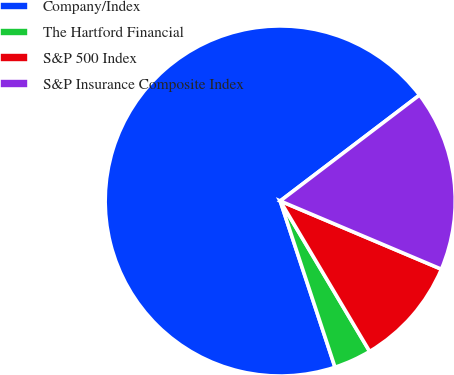<chart> <loc_0><loc_0><loc_500><loc_500><pie_chart><fcel>Company/Index<fcel>The Hartford Financial<fcel>S&P 500 Index<fcel>S&P Insurance Composite Index<nl><fcel>69.72%<fcel>3.47%<fcel>10.09%<fcel>16.72%<nl></chart> 